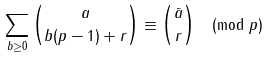Convert formula to latex. <formula><loc_0><loc_0><loc_500><loc_500>\sum _ { b \geq 0 } \binom { a } { b ( p - 1 ) + r } \equiv \binom { \bar { a } } { r } \pmod { p }</formula> 